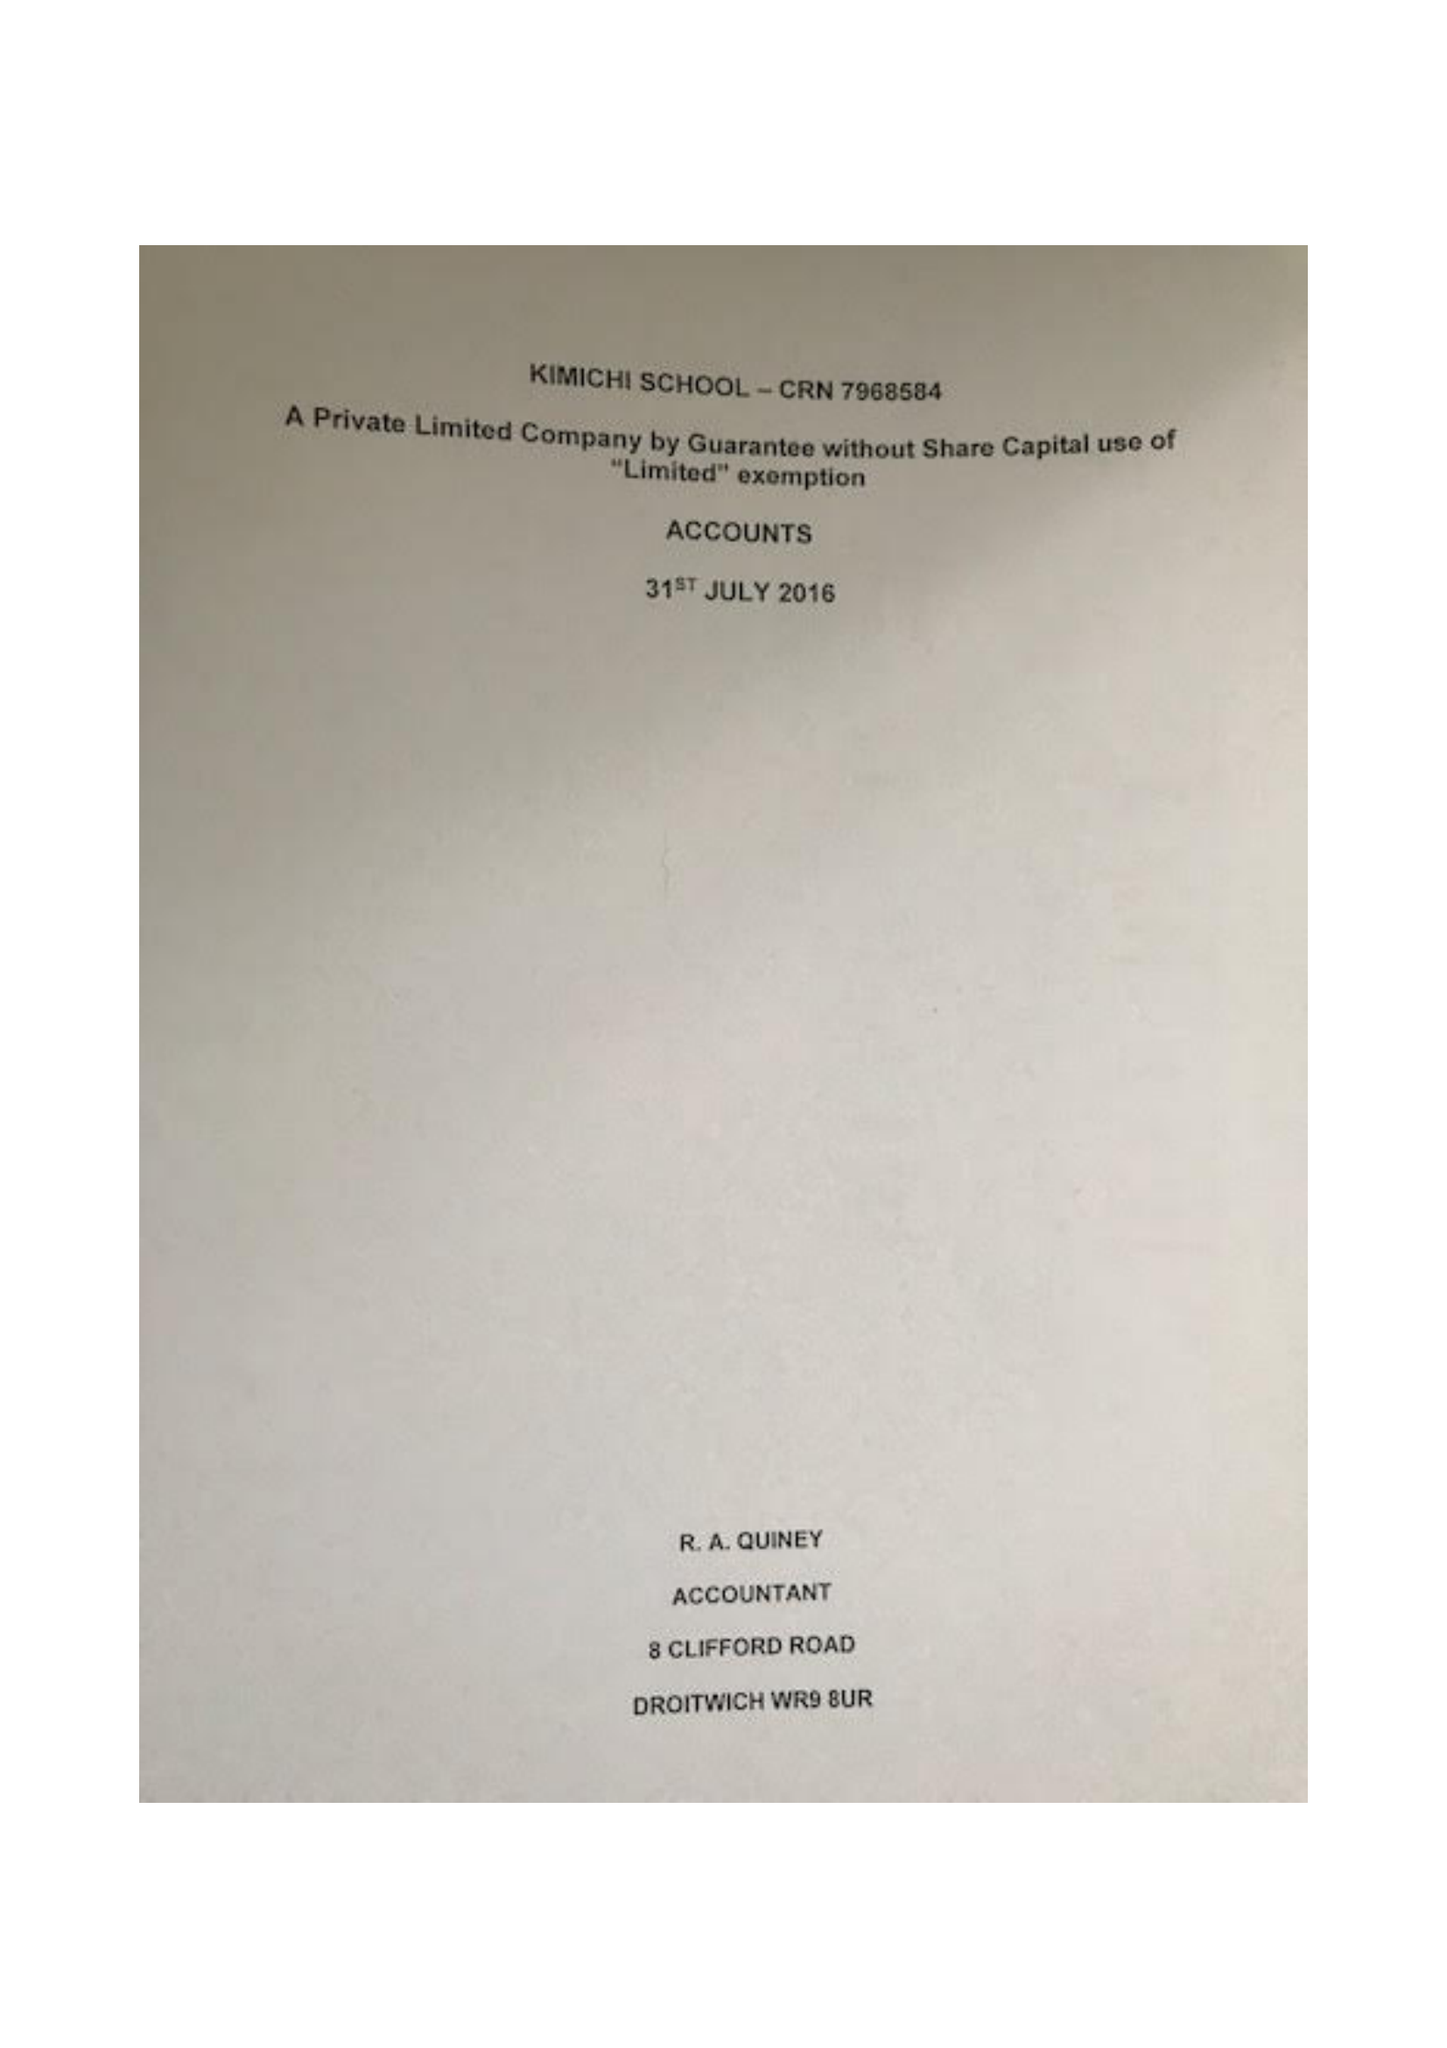What is the value for the address__street_line?
Answer the question using a single word or phrase. 111 YARDLEY ROAD 